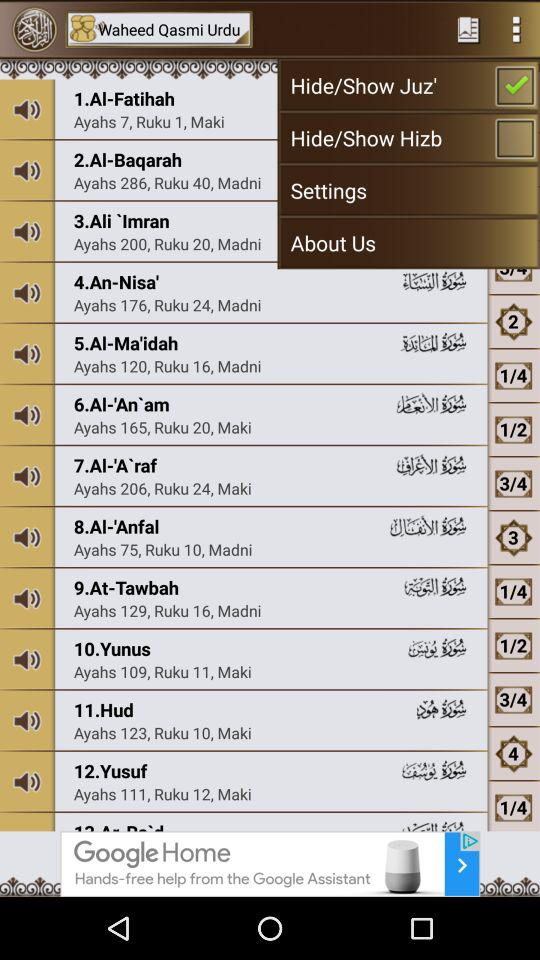What is the number of madni in Al-Fatihah?
When the provided information is insufficient, respond with <no answer>. <no answer> 